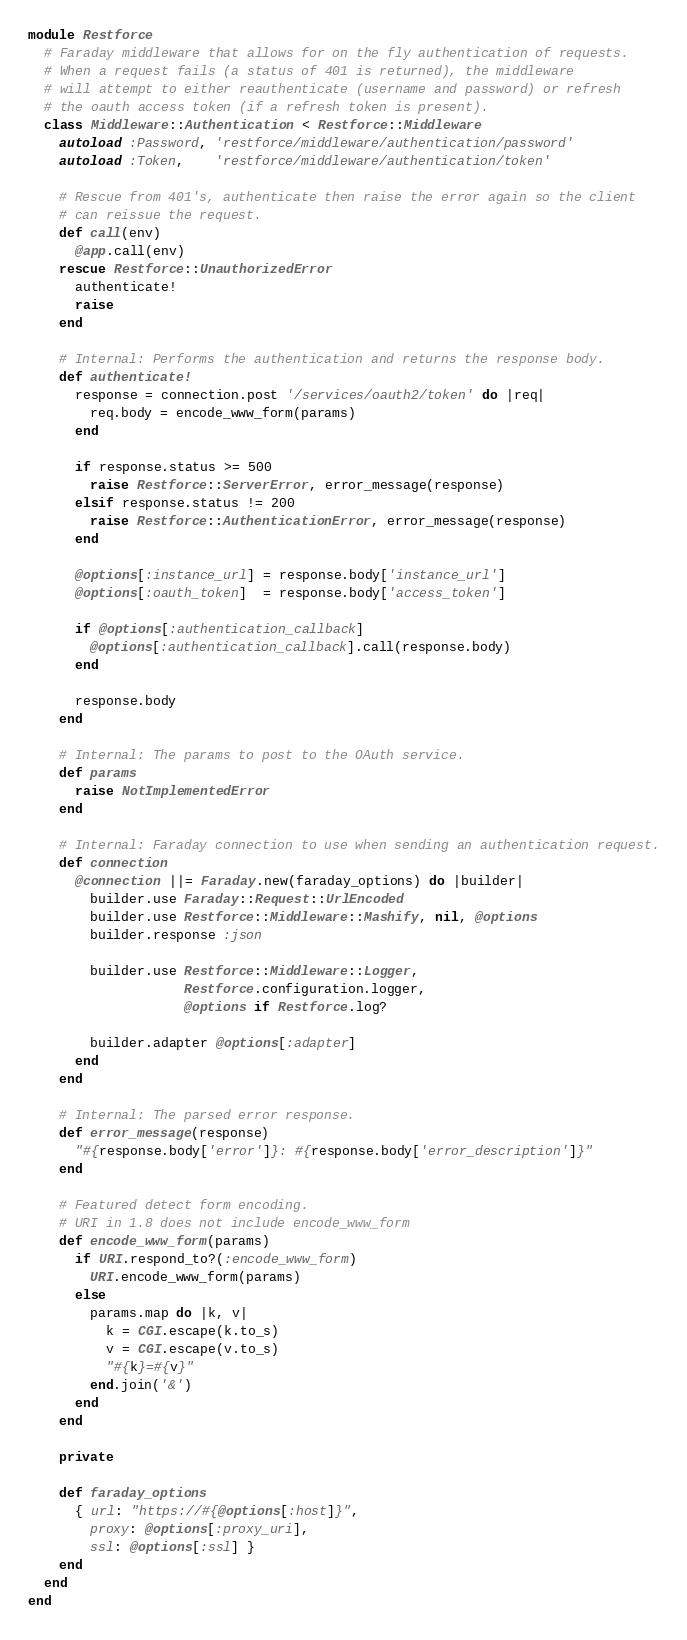<code> <loc_0><loc_0><loc_500><loc_500><_Ruby_>module Restforce
  # Faraday middleware that allows for on the fly authentication of requests.
  # When a request fails (a status of 401 is returned), the middleware
  # will attempt to either reauthenticate (username and password) or refresh
  # the oauth access token (if a refresh token is present).
  class Middleware::Authentication < Restforce::Middleware
    autoload :Password, 'restforce/middleware/authentication/password'
    autoload :Token,    'restforce/middleware/authentication/token'

    # Rescue from 401's, authenticate then raise the error again so the client
    # can reissue the request.
    def call(env)
      @app.call(env)
    rescue Restforce::UnauthorizedError
      authenticate!
      raise
    end

    # Internal: Performs the authentication and returns the response body.
    def authenticate!
      response = connection.post '/services/oauth2/token' do |req|
        req.body = encode_www_form(params)
      end

      if response.status >= 500
        raise Restforce::ServerError, error_message(response)
      elsif response.status != 200
        raise Restforce::AuthenticationError, error_message(response)
      end

      @options[:instance_url] = response.body['instance_url']
      @options[:oauth_token]  = response.body['access_token']

      if @options[:authentication_callback]
        @options[:authentication_callback].call(response.body)
      end

      response.body
    end

    # Internal: The params to post to the OAuth service.
    def params
      raise NotImplementedError
    end

    # Internal: Faraday connection to use when sending an authentication request.
    def connection
      @connection ||= Faraday.new(faraday_options) do |builder|
        builder.use Faraday::Request::UrlEncoded
        builder.use Restforce::Middleware::Mashify, nil, @options
        builder.response :json

        builder.use Restforce::Middleware::Logger,
                    Restforce.configuration.logger,
                    @options if Restforce.log?

        builder.adapter @options[:adapter]
      end
    end

    # Internal: The parsed error response.
    def error_message(response)
      "#{response.body['error']}: #{response.body['error_description']}"
    end

    # Featured detect form encoding.
    # URI in 1.8 does not include encode_www_form
    def encode_www_form(params)
      if URI.respond_to?(:encode_www_form)
        URI.encode_www_form(params)
      else
        params.map do |k, v|
          k = CGI.escape(k.to_s)
          v = CGI.escape(v.to_s)
          "#{k}=#{v}"
        end.join('&')
      end
    end

    private

    def faraday_options
      { url: "https://#{@options[:host]}",
        proxy: @options[:proxy_uri],
        ssl: @options[:ssl] }
    end
  end
end
</code> 